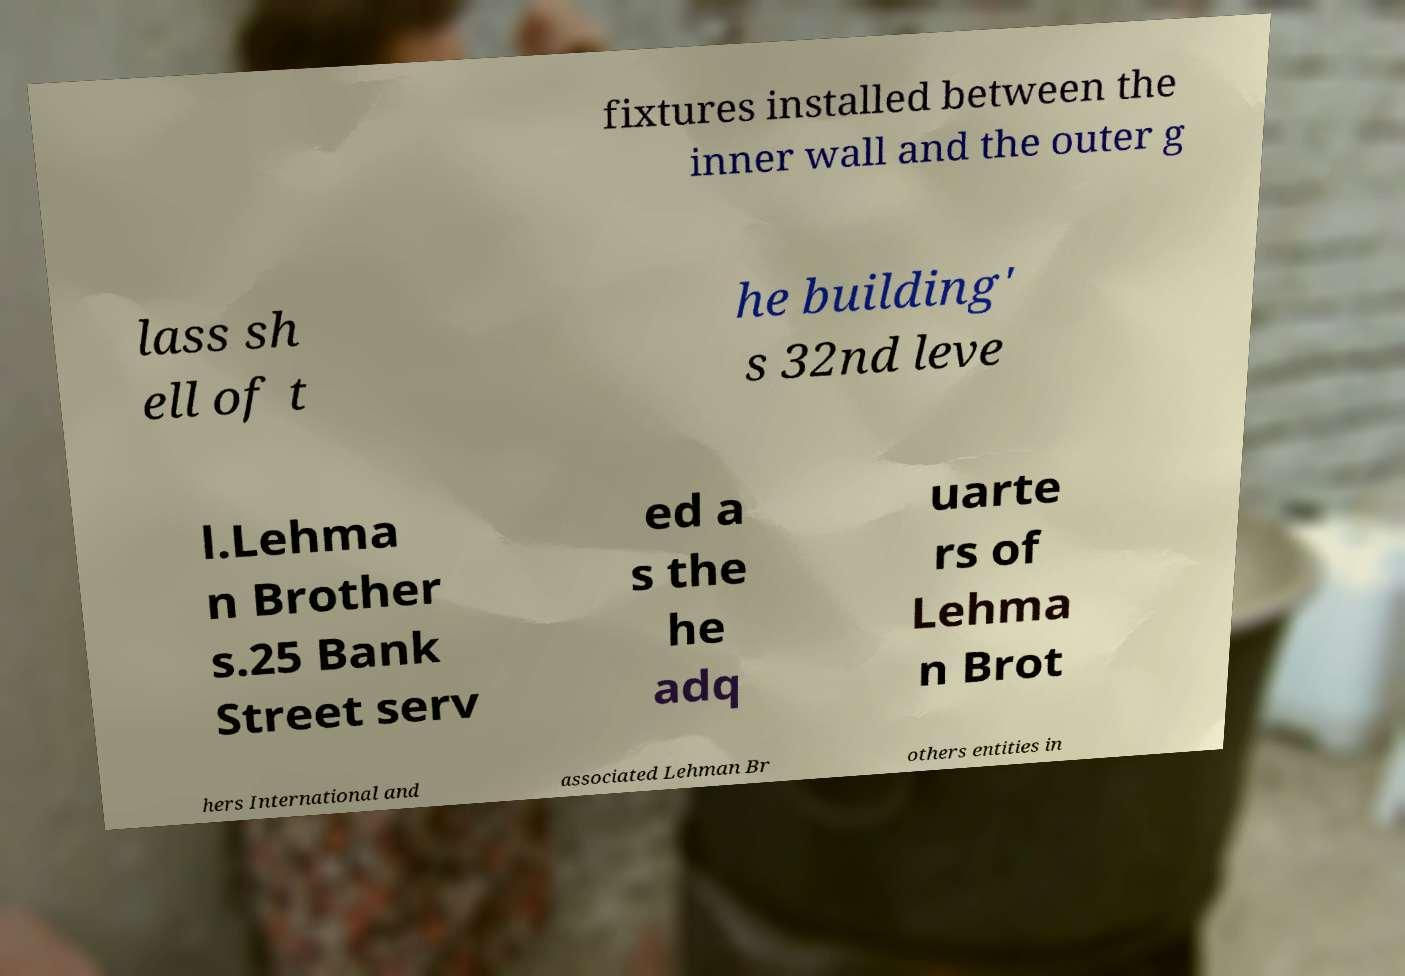Please read and relay the text visible in this image. What does it say? fixtures installed between the inner wall and the outer g lass sh ell of t he building' s 32nd leve l.Lehma n Brother s.25 Bank Street serv ed a s the he adq uarte rs of Lehma n Brot hers International and associated Lehman Br others entities in 